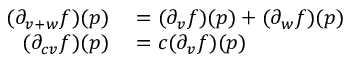Convert formula to latex. <formula><loc_0><loc_0><loc_500><loc_500>\begin{array} { r l } { ( \partial _ { v + w } f ) ( p ) } & = ( \partial _ { v } f ) ( p ) + ( \partial _ { w } f ) ( p ) } \\ { ( \partial _ { c v } f ) ( p ) } & = c ( \partial _ { v } f ) ( p ) } \end{array}</formula> 